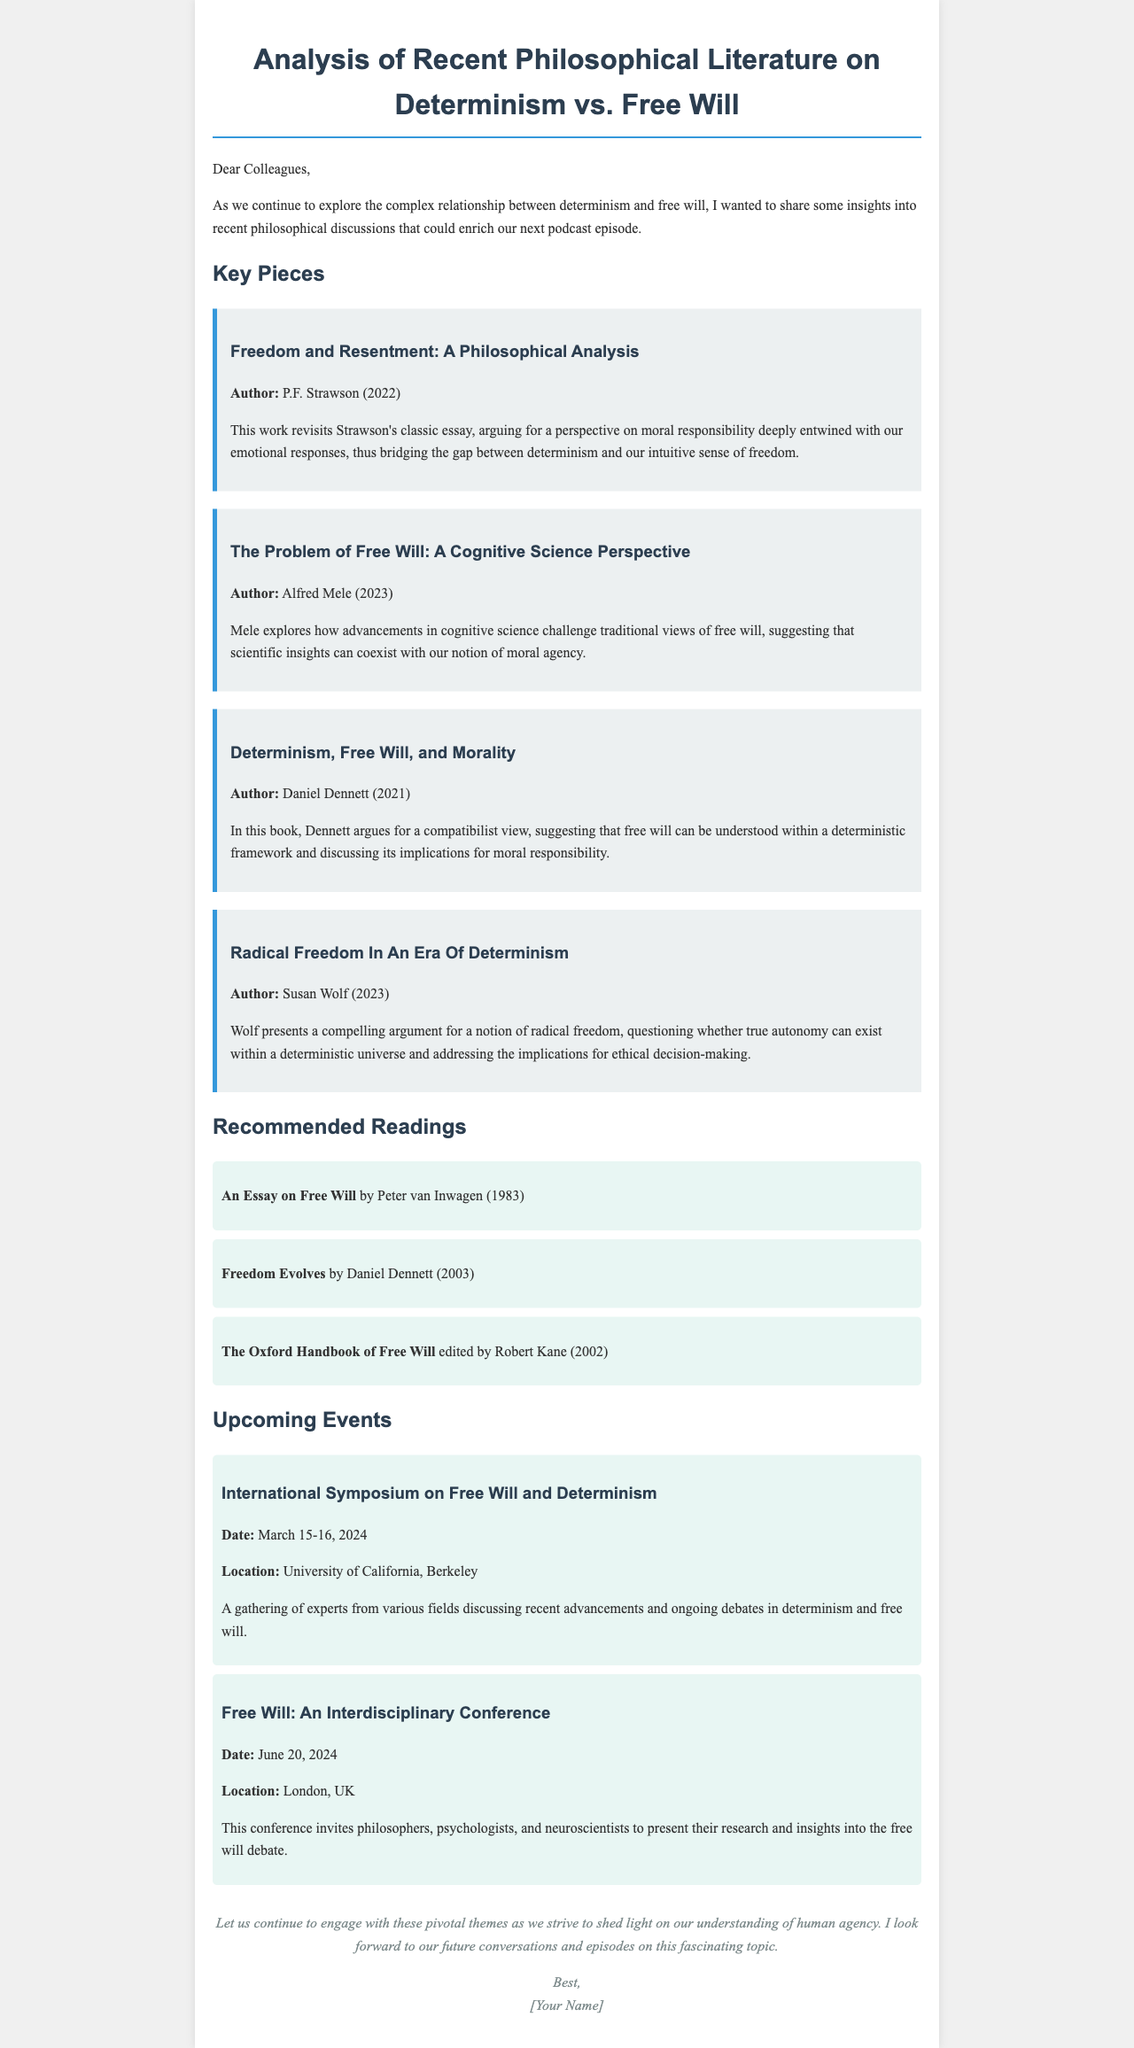What is the title of the document? The title is mentioned in the header of the rendered document, which is about the philosophical analysis on determinism and free will.
Answer: Analysis of Recent Philosophical Literature on Determinism vs. Free Will Who authored "Freedom and Resentment: A Philosophical Analysis"? The author of this key piece is indicated in the document as part of the bibliographic details.
Answer: P.F. Strawson In which year was "The Problem of Free Will: A Cognitive Science Perspective" published? The year of publication is explicitly stated in the description of the key piece.
Answer: 2023 What is the location of the International Symposium on Free Will and Determinism? The location is provided in the details of the upcoming event section.
Answer: University of California, Berkeley How many key pieces are mentioned in the document? The document lists the number of key pieces under the "Key Pieces" section.
Answer: Four What is the date of the Free Will: An Interdisciplinary Conference? The date is provided in the summary of the upcoming events in the document.
Answer: June 20, 2024 Which philosopher advocates a compatibilist view in the document? The document gives a clear indication of the author's philosophical stance regarding compatibilism.
Answer: Daniel Dennett What genre of literature does the document focus on? The genre is evident from the context and content described throughout the document.
Answer: Philosophical literature 